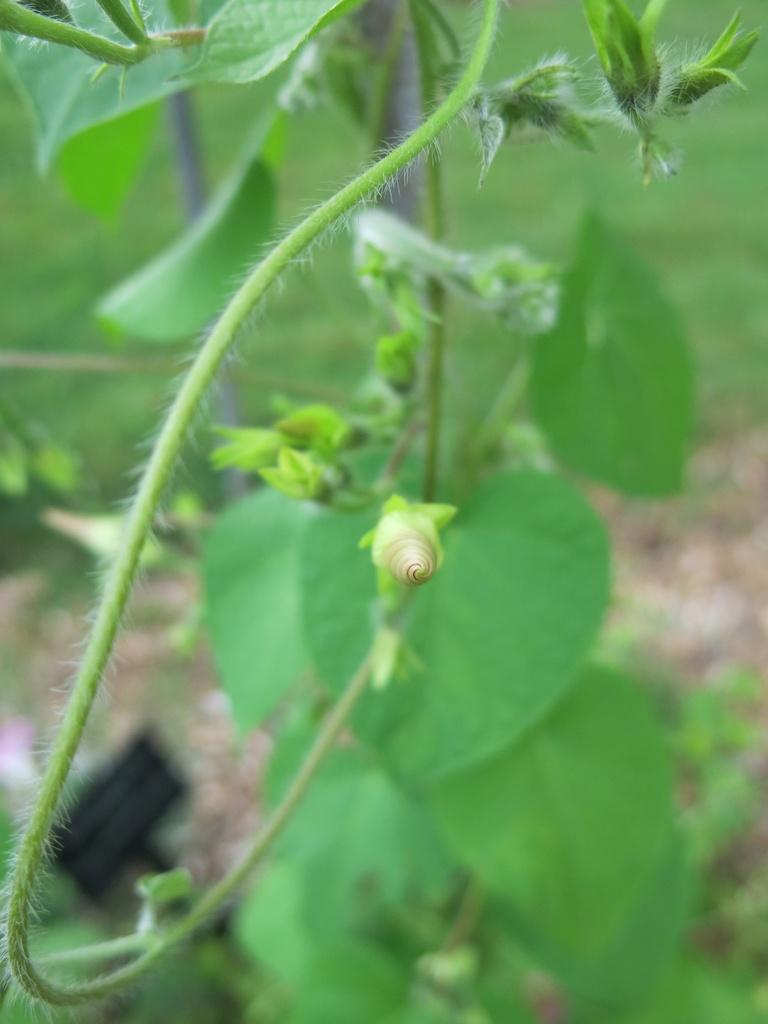What is located in the front of the image? There are plants in the front of the image. What color dominates the background of the image? The background of the image is green. What type of lunchroom can be seen in the image? There is no lunchroom present in the image; it features plants in the front and a green background. 